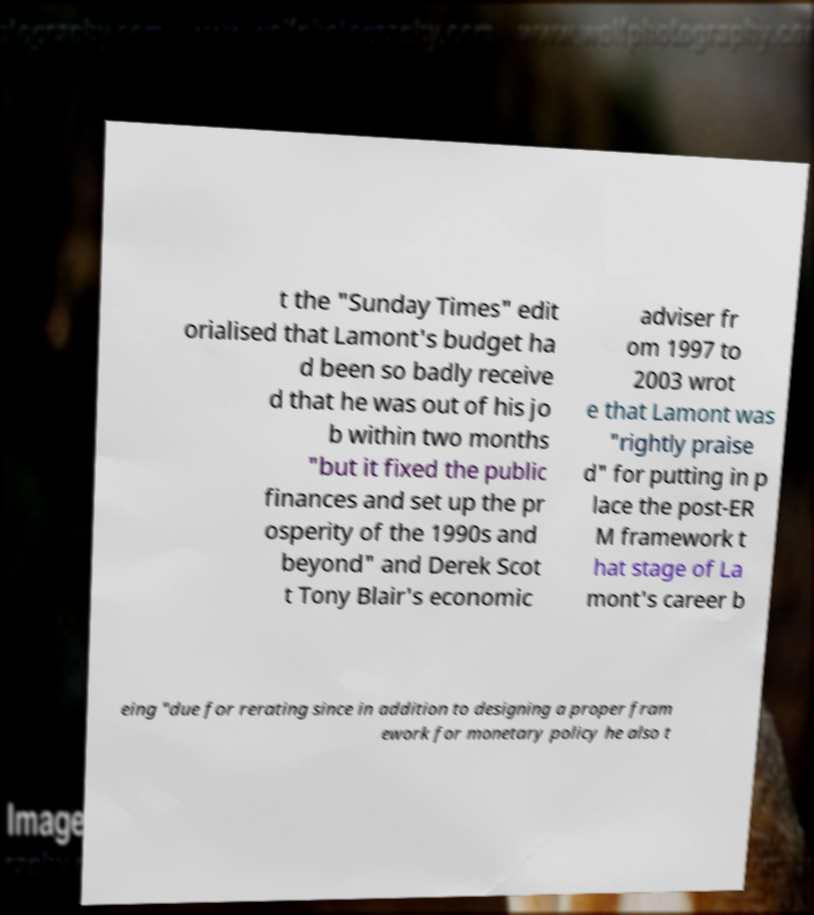Can you accurately transcribe the text from the provided image for me? t the "Sunday Times" edit orialised that Lamont's budget ha d been so badly receive d that he was out of his jo b within two months "but it fixed the public finances and set up the pr osperity of the 1990s and beyond" and Derek Scot t Tony Blair's economic adviser fr om 1997 to 2003 wrot e that Lamont was "rightly praise d" for putting in p lace the post-ER M framework t hat stage of La mont's career b eing "due for rerating since in addition to designing a proper fram ework for monetary policy he also t 